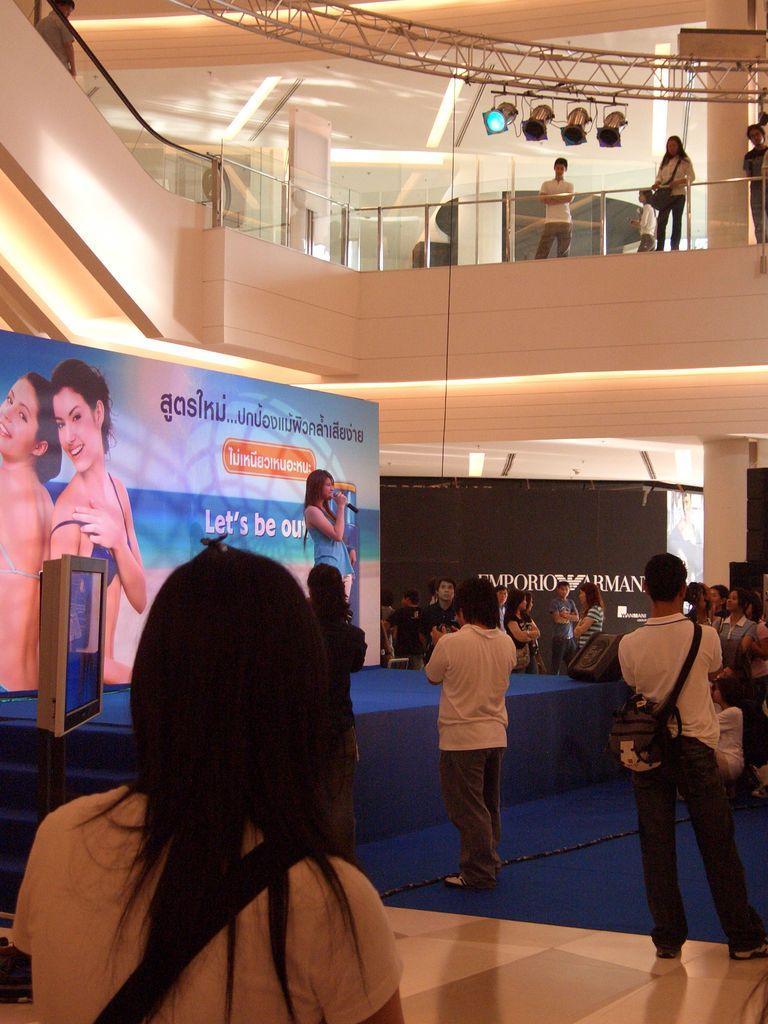Could you give a brief overview of what you see in this image? In the image there are few people standing. There is a stage with blue carpet and also there is a lady standing and holding the mic in her hand. Behind her there is a poster. And also there is a pole with the screen. There is a glass railing. Behind the railing there are few people standing and also there are pillars. There is a black color poster and also at the top of the image there are rods with lights are hanging onto it. 